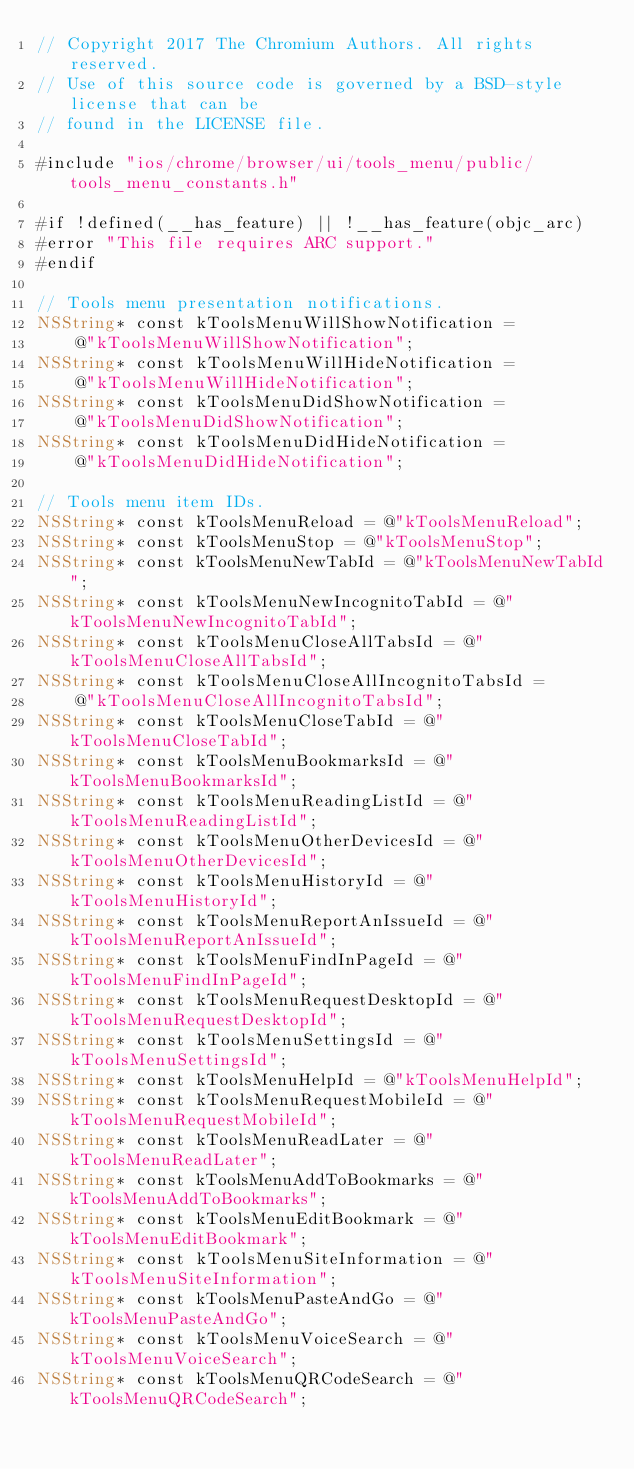<code> <loc_0><loc_0><loc_500><loc_500><_ObjectiveC_>// Copyright 2017 The Chromium Authors. All rights reserved.
// Use of this source code is governed by a BSD-style license that can be
// found in the LICENSE file.

#include "ios/chrome/browser/ui/tools_menu/public/tools_menu_constants.h"

#if !defined(__has_feature) || !__has_feature(objc_arc)
#error "This file requires ARC support."
#endif

// Tools menu presentation notifications.
NSString* const kToolsMenuWillShowNotification =
    @"kToolsMenuWillShowNotification";
NSString* const kToolsMenuWillHideNotification =
    @"kToolsMenuWillHideNotification";
NSString* const kToolsMenuDidShowNotification =
    @"kToolsMenuDidShowNotification";
NSString* const kToolsMenuDidHideNotification =
    @"kToolsMenuDidHideNotification";

// Tools menu item IDs.
NSString* const kToolsMenuReload = @"kToolsMenuReload";
NSString* const kToolsMenuStop = @"kToolsMenuStop";
NSString* const kToolsMenuNewTabId = @"kToolsMenuNewTabId";
NSString* const kToolsMenuNewIncognitoTabId = @"kToolsMenuNewIncognitoTabId";
NSString* const kToolsMenuCloseAllTabsId = @"kToolsMenuCloseAllTabsId";
NSString* const kToolsMenuCloseAllIncognitoTabsId =
    @"kToolsMenuCloseAllIncognitoTabsId";
NSString* const kToolsMenuCloseTabId = @"kToolsMenuCloseTabId";
NSString* const kToolsMenuBookmarksId = @"kToolsMenuBookmarksId";
NSString* const kToolsMenuReadingListId = @"kToolsMenuReadingListId";
NSString* const kToolsMenuOtherDevicesId = @"kToolsMenuOtherDevicesId";
NSString* const kToolsMenuHistoryId = @"kToolsMenuHistoryId";
NSString* const kToolsMenuReportAnIssueId = @"kToolsMenuReportAnIssueId";
NSString* const kToolsMenuFindInPageId = @"kToolsMenuFindInPageId";
NSString* const kToolsMenuRequestDesktopId = @"kToolsMenuRequestDesktopId";
NSString* const kToolsMenuSettingsId = @"kToolsMenuSettingsId";
NSString* const kToolsMenuHelpId = @"kToolsMenuHelpId";
NSString* const kToolsMenuRequestMobileId = @"kToolsMenuRequestMobileId";
NSString* const kToolsMenuReadLater = @"kToolsMenuReadLater";
NSString* const kToolsMenuAddToBookmarks = @"kToolsMenuAddToBookmarks";
NSString* const kToolsMenuEditBookmark = @"kToolsMenuEditBookmark";
NSString* const kToolsMenuSiteInformation = @"kToolsMenuSiteInformation";
NSString* const kToolsMenuPasteAndGo = @"kToolsMenuPasteAndGo";
NSString* const kToolsMenuVoiceSearch = @"kToolsMenuVoiceSearch";
NSString* const kToolsMenuQRCodeSearch = @"kToolsMenuQRCodeSearch";
</code> 